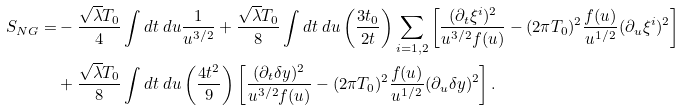<formula> <loc_0><loc_0><loc_500><loc_500>S _ { N G } = & - \frac { \sqrt { \lambda } T _ { 0 } } { 4 } \int d t \ d u \frac { 1 } { u ^ { 3 / 2 } } + \frac { \sqrt { \lambda } T _ { 0 } } { 8 } \int d t \ d u \left ( \frac { 3 t _ { 0 } } { 2 t } \right ) \sum _ { i = 1 , 2 } \left [ \frac { ( \partial _ { t } \xi ^ { i } ) ^ { 2 } } { u ^ { 3 / 2 } f ( u ) } - ( 2 \pi T _ { 0 } ) ^ { 2 } \frac { f ( u ) } { u ^ { 1 / 2 } } ( \partial _ { u } \xi ^ { i } ) ^ { 2 } \right ] \\ & + \frac { \sqrt { \lambda } T _ { 0 } } { 8 } \int d t \ d u \left ( \frac { 4 t ^ { 2 } } { 9 } \right ) \left [ \frac { ( \partial _ { t } \delta y ) ^ { 2 } } { u ^ { 3 / 2 } f ( u ) } - ( 2 \pi T _ { 0 } ) ^ { 2 } \frac { f ( u ) } { u ^ { 1 / 2 } } ( \partial _ { u } \delta y ) ^ { 2 } \right ] .</formula> 